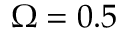<formula> <loc_0><loc_0><loc_500><loc_500>\Omega = 0 . 5</formula> 